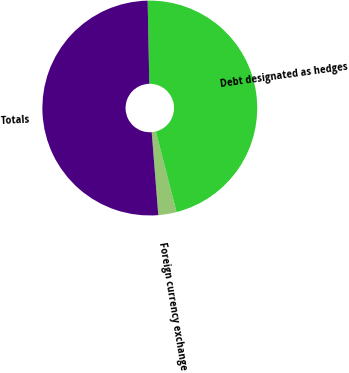<chart> <loc_0><loc_0><loc_500><loc_500><pie_chart><fcel>Foreign currency exchange<fcel>Debt designated as hedges<fcel>Totals<nl><fcel>2.75%<fcel>46.31%<fcel>50.94%<nl></chart> 